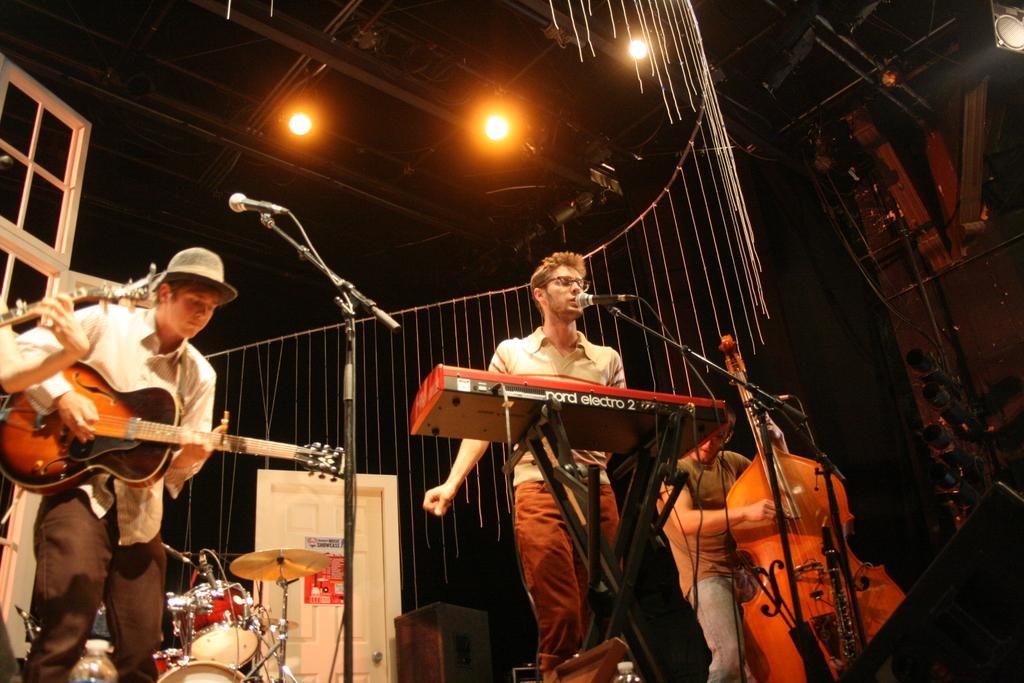Could you give a brief overview of what you see in this image? In the image we can see there are people who are standing and they are playing musical instruments and in front of them there is mic with a stand. At the back there is a drum set and on the top there are lightings and the man in the corner is wearing hat. 